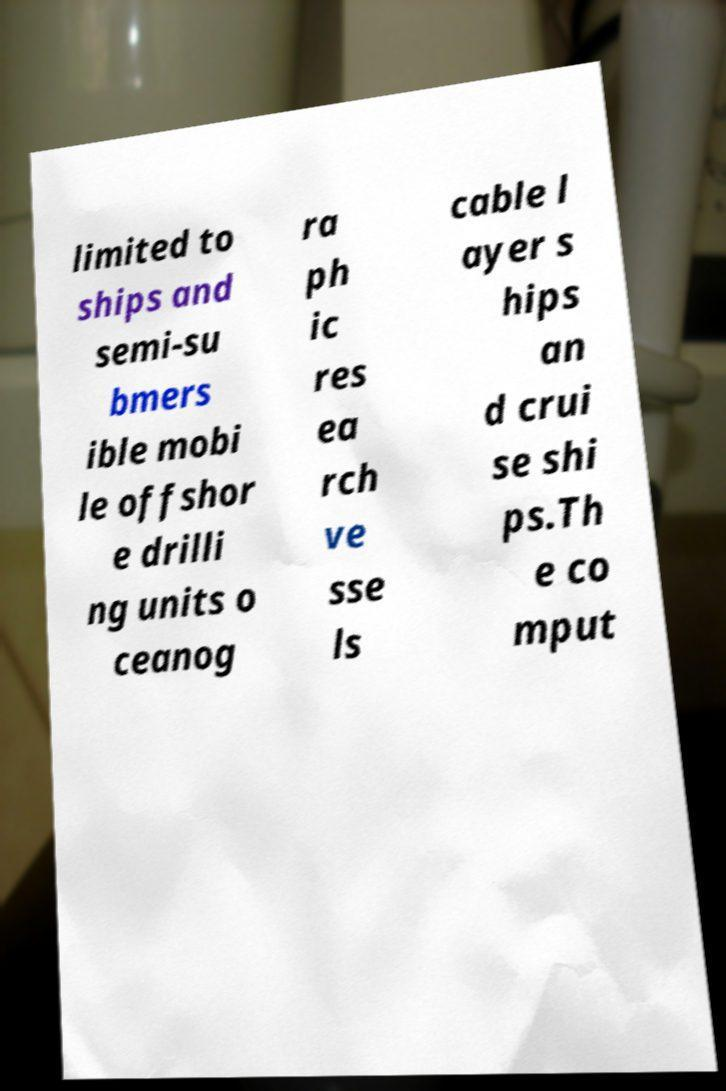Can you read and provide the text displayed in the image?This photo seems to have some interesting text. Can you extract and type it out for me? limited to ships and semi-su bmers ible mobi le offshor e drilli ng units o ceanog ra ph ic res ea rch ve sse ls cable l ayer s hips an d crui se shi ps.Th e co mput 